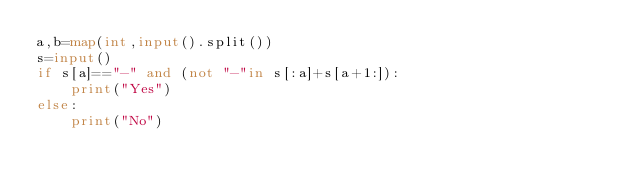Convert code to text. <code><loc_0><loc_0><loc_500><loc_500><_Python_>a,b=map(int,input().split())
s=input()
if s[a]=="-" and (not "-"in s[:a]+s[a+1:]):
    print("Yes")
else:
    print("No")</code> 